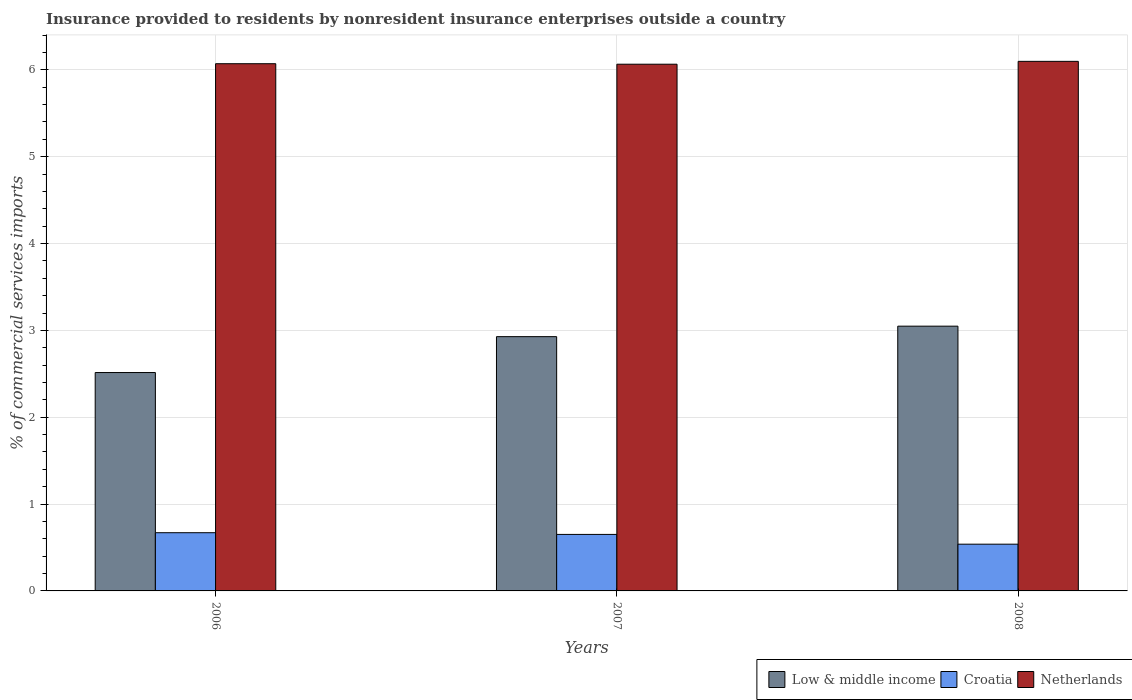How many groups of bars are there?
Offer a terse response. 3. Are the number of bars on each tick of the X-axis equal?
Keep it short and to the point. Yes. How many bars are there on the 2nd tick from the left?
Your response must be concise. 3. How many bars are there on the 2nd tick from the right?
Keep it short and to the point. 3. In how many cases, is the number of bars for a given year not equal to the number of legend labels?
Your answer should be compact. 0. What is the Insurance provided to residents in Croatia in 2008?
Make the answer very short. 0.54. Across all years, what is the maximum Insurance provided to residents in Low & middle income?
Ensure brevity in your answer.  3.05. Across all years, what is the minimum Insurance provided to residents in Croatia?
Keep it short and to the point. 0.54. In which year was the Insurance provided to residents in Croatia maximum?
Provide a short and direct response. 2006. What is the total Insurance provided to residents in Low & middle income in the graph?
Your answer should be compact. 8.49. What is the difference between the Insurance provided to residents in Low & middle income in 2006 and that in 2008?
Ensure brevity in your answer.  -0.53. What is the difference between the Insurance provided to residents in Low & middle income in 2007 and the Insurance provided to residents in Netherlands in 2006?
Offer a very short reply. -3.14. What is the average Insurance provided to residents in Netherlands per year?
Your answer should be compact. 6.08. In the year 2008, what is the difference between the Insurance provided to residents in Netherlands and Insurance provided to residents in Croatia?
Offer a terse response. 5.56. In how many years, is the Insurance provided to residents in Netherlands greater than 3.2 %?
Keep it short and to the point. 3. What is the ratio of the Insurance provided to residents in Low & middle income in 2007 to that in 2008?
Keep it short and to the point. 0.96. Is the Insurance provided to residents in Netherlands in 2007 less than that in 2008?
Make the answer very short. Yes. Is the difference between the Insurance provided to residents in Netherlands in 2007 and 2008 greater than the difference between the Insurance provided to residents in Croatia in 2007 and 2008?
Keep it short and to the point. No. What is the difference between the highest and the second highest Insurance provided to residents in Low & middle income?
Your answer should be compact. 0.12. What is the difference between the highest and the lowest Insurance provided to residents in Croatia?
Ensure brevity in your answer.  0.13. In how many years, is the Insurance provided to residents in Low & middle income greater than the average Insurance provided to residents in Low & middle income taken over all years?
Your answer should be very brief. 2. What does the 2nd bar from the left in 2006 represents?
Your answer should be very brief. Croatia. What does the 1st bar from the right in 2007 represents?
Offer a very short reply. Netherlands. How many bars are there?
Your answer should be compact. 9. How many years are there in the graph?
Your response must be concise. 3. Are the values on the major ticks of Y-axis written in scientific E-notation?
Your response must be concise. No. Does the graph contain any zero values?
Keep it short and to the point. No. How are the legend labels stacked?
Provide a short and direct response. Horizontal. What is the title of the graph?
Offer a very short reply. Insurance provided to residents by nonresident insurance enterprises outside a country. Does "Sao Tome and Principe" appear as one of the legend labels in the graph?
Your answer should be compact. No. What is the label or title of the X-axis?
Provide a succinct answer. Years. What is the label or title of the Y-axis?
Give a very brief answer. % of commercial services imports. What is the % of commercial services imports in Low & middle income in 2006?
Offer a very short reply. 2.51. What is the % of commercial services imports in Croatia in 2006?
Provide a short and direct response. 0.67. What is the % of commercial services imports in Netherlands in 2006?
Provide a succinct answer. 6.07. What is the % of commercial services imports of Low & middle income in 2007?
Ensure brevity in your answer.  2.93. What is the % of commercial services imports in Croatia in 2007?
Offer a terse response. 0.65. What is the % of commercial services imports in Netherlands in 2007?
Provide a short and direct response. 6.06. What is the % of commercial services imports of Low & middle income in 2008?
Provide a succinct answer. 3.05. What is the % of commercial services imports in Croatia in 2008?
Offer a terse response. 0.54. What is the % of commercial services imports in Netherlands in 2008?
Your answer should be compact. 6.1. Across all years, what is the maximum % of commercial services imports in Low & middle income?
Offer a terse response. 3.05. Across all years, what is the maximum % of commercial services imports of Croatia?
Your answer should be very brief. 0.67. Across all years, what is the maximum % of commercial services imports of Netherlands?
Your answer should be very brief. 6.1. Across all years, what is the minimum % of commercial services imports in Low & middle income?
Make the answer very short. 2.51. Across all years, what is the minimum % of commercial services imports in Croatia?
Your answer should be compact. 0.54. Across all years, what is the minimum % of commercial services imports in Netherlands?
Your answer should be compact. 6.06. What is the total % of commercial services imports in Low & middle income in the graph?
Ensure brevity in your answer.  8.49. What is the total % of commercial services imports in Croatia in the graph?
Your answer should be compact. 1.86. What is the total % of commercial services imports of Netherlands in the graph?
Provide a short and direct response. 18.23. What is the difference between the % of commercial services imports in Low & middle income in 2006 and that in 2007?
Give a very brief answer. -0.41. What is the difference between the % of commercial services imports in Croatia in 2006 and that in 2007?
Your answer should be compact. 0.02. What is the difference between the % of commercial services imports of Netherlands in 2006 and that in 2007?
Your answer should be compact. 0.01. What is the difference between the % of commercial services imports in Low & middle income in 2006 and that in 2008?
Ensure brevity in your answer.  -0.53. What is the difference between the % of commercial services imports in Croatia in 2006 and that in 2008?
Offer a very short reply. 0.13. What is the difference between the % of commercial services imports in Netherlands in 2006 and that in 2008?
Ensure brevity in your answer.  -0.03. What is the difference between the % of commercial services imports in Low & middle income in 2007 and that in 2008?
Offer a terse response. -0.12. What is the difference between the % of commercial services imports in Croatia in 2007 and that in 2008?
Provide a succinct answer. 0.11. What is the difference between the % of commercial services imports in Netherlands in 2007 and that in 2008?
Provide a short and direct response. -0.03. What is the difference between the % of commercial services imports of Low & middle income in 2006 and the % of commercial services imports of Croatia in 2007?
Offer a very short reply. 1.86. What is the difference between the % of commercial services imports in Low & middle income in 2006 and the % of commercial services imports in Netherlands in 2007?
Give a very brief answer. -3.55. What is the difference between the % of commercial services imports of Croatia in 2006 and the % of commercial services imports of Netherlands in 2007?
Keep it short and to the point. -5.39. What is the difference between the % of commercial services imports of Low & middle income in 2006 and the % of commercial services imports of Croatia in 2008?
Keep it short and to the point. 1.98. What is the difference between the % of commercial services imports of Low & middle income in 2006 and the % of commercial services imports of Netherlands in 2008?
Make the answer very short. -3.58. What is the difference between the % of commercial services imports in Croatia in 2006 and the % of commercial services imports in Netherlands in 2008?
Offer a terse response. -5.43. What is the difference between the % of commercial services imports in Low & middle income in 2007 and the % of commercial services imports in Croatia in 2008?
Provide a short and direct response. 2.39. What is the difference between the % of commercial services imports in Low & middle income in 2007 and the % of commercial services imports in Netherlands in 2008?
Offer a very short reply. -3.17. What is the difference between the % of commercial services imports in Croatia in 2007 and the % of commercial services imports in Netherlands in 2008?
Your response must be concise. -5.45. What is the average % of commercial services imports in Low & middle income per year?
Make the answer very short. 2.83. What is the average % of commercial services imports in Croatia per year?
Your answer should be compact. 0.62. What is the average % of commercial services imports of Netherlands per year?
Give a very brief answer. 6.08. In the year 2006, what is the difference between the % of commercial services imports in Low & middle income and % of commercial services imports in Croatia?
Your response must be concise. 1.84. In the year 2006, what is the difference between the % of commercial services imports of Low & middle income and % of commercial services imports of Netherlands?
Provide a succinct answer. -3.56. In the year 2006, what is the difference between the % of commercial services imports in Croatia and % of commercial services imports in Netherlands?
Offer a very short reply. -5.4. In the year 2007, what is the difference between the % of commercial services imports in Low & middle income and % of commercial services imports in Croatia?
Give a very brief answer. 2.28. In the year 2007, what is the difference between the % of commercial services imports of Low & middle income and % of commercial services imports of Netherlands?
Give a very brief answer. -3.14. In the year 2007, what is the difference between the % of commercial services imports of Croatia and % of commercial services imports of Netherlands?
Make the answer very short. -5.41. In the year 2008, what is the difference between the % of commercial services imports in Low & middle income and % of commercial services imports in Croatia?
Offer a terse response. 2.51. In the year 2008, what is the difference between the % of commercial services imports of Low & middle income and % of commercial services imports of Netherlands?
Make the answer very short. -3.05. In the year 2008, what is the difference between the % of commercial services imports of Croatia and % of commercial services imports of Netherlands?
Provide a succinct answer. -5.56. What is the ratio of the % of commercial services imports of Low & middle income in 2006 to that in 2007?
Your answer should be compact. 0.86. What is the ratio of the % of commercial services imports of Croatia in 2006 to that in 2007?
Provide a short and direct response. 1.03. What is the ratio of the % of commercial services imports in Netherlands in 2006 to that in 2007?
Keep it short and to the point. 1. What is the ratio of the % of commercial services imports in Low & middle income in 2006 to that in 2008?
Your answer should be compact. 0.82. What is the ratio of the % of commercial services imports in Croatia in 2006 to that in 2008?
Ensure brevity in your answer.  1.25. What is the ratio of the % of commercial services imports in Netherlands in 2006 to that in 2008?
Offer a terse response. 1. What is the ratio of the % of commercial services imports in Low & middle income in 2007 to that in 2008?
Make the answer very short. 0.96. What is the ratio of the % of commercial services imports in Croatia in 2007 to that in 2008?
Offer a very short reply. 1.21. What is the difference between the highest and the second highest % of commercial services imports of Low & middle income?
Your response must be concise. 0.12. What is the difference between the highest and the second highest % of commercial services imports in Croatia?
Ensure brevity in your answer.  0.02. What is the difference between the highest and the second highest % of commercial services imports in Netherlands?
Offer a very short reply. 0.03. What is the difference between the highest and the lowest % of commercial services imports in Low & middle income?
Provide a short and direct response. 0.53. What is the difference between the highest and the lowest % of commercial services imports in Croatia?
Give a very brief answer. 0.13. What is the difference between the highest and the lowest % of commercial services imports in Netherlands?
Your response must be concise. 0.03. 